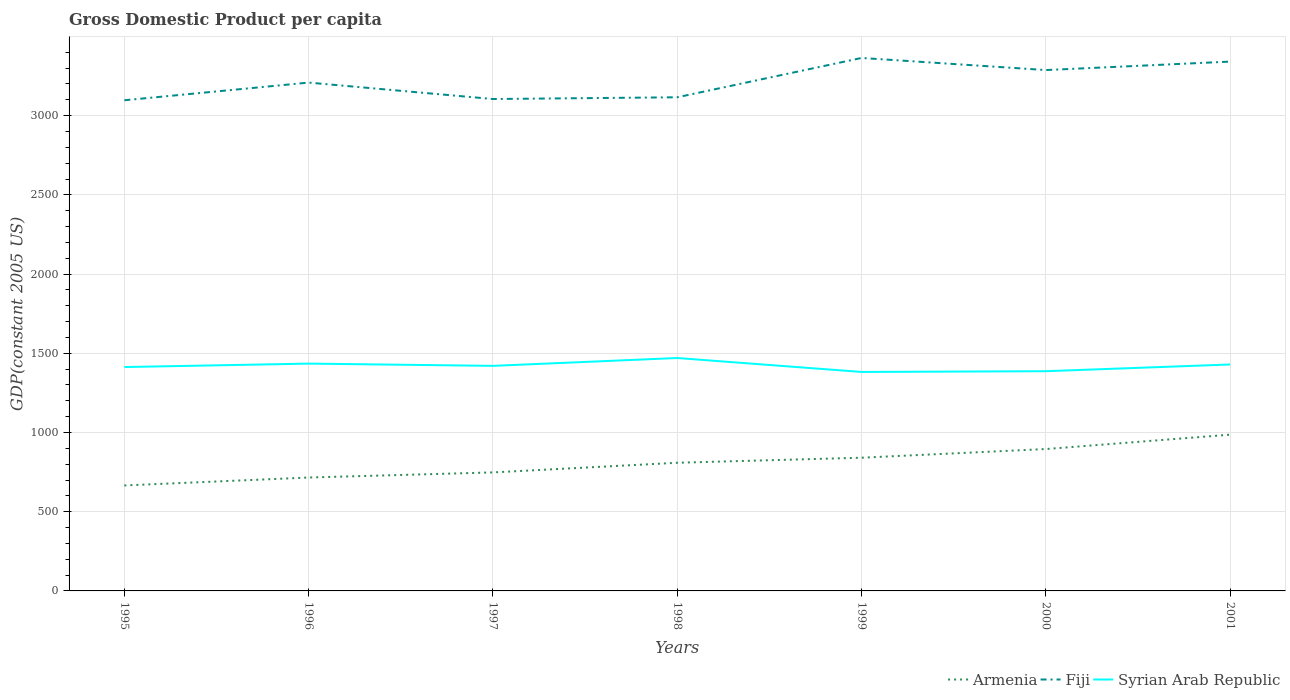Does the line corresponding to Syrian Arab Republic intersect with the line corresponding to Fiji?
Give a very brief answer. No. Is the number of lines equal to the number of legend labels?
Your response must be concise. Yes. Across all years, what is the maximum GDP per capita in Armenia?
Your answer should be very brief. 665.72. What is the total GDP per capita in Fiji in the graph?
Give a very brief answer. -267.04. What is the difference between the highest and the second highest GDP per capita in Syrian Arab Republic?
Your response must be concise. 88.08. What is the difference between the highest and the lowest GDP per capita in Syrian Arab Republic?
Offer a very short reply. 4. How many years are there in the graph?
Give a very brief answer. 7. Are the values on the major ticks of Y-axis written in scientific E-notation?
Offer a very short reply. No. Does the graph contain any zero values?
Make the answer very short. No. Does the graph contain grids?
Your answer should be very brief. Yes. Where does the legend appear in the graph?
Provide a short and direct response. Bottom right. How many legend labels are there?
Provide a succinct answer. 3. How are the legend labels stacked?
Provide a short and direct response. Horizontal. What is the title of the graph?
Your response must be concise. Gross Domestic Product per capita. What is the label or title of the X-axis?
Offer a very short reply. Years. What is the label or title of the Y-axis?
Give a very brief answer. GDP(constant 2005 US). What is the GDP(constant 2005 US) of Armenia in 1995?
Give a very brief answer. 665.72. What is the GDP(constant 2005 US) of Fiji in 1995?
Offer a very short reply. 3097.15. What is the GDP(constant 2005 US) of Syrian Arab Republic in 1995?
Ensure brevity in your answer.  1413.15. What is the GDP(constant 2005 US) of Armenia in 1996?
Make the answer very short. 715.82. What is the GDP(constant 2005 US) of Fiji in 1996?
Your answer should be very brief. 3208.65. What is the GDP(constant 2005 US) in Syrian Arab Republic in 1996?
Give a very brief answer. 1434.86. What is the GDP(constant 2005 US) in Armenia in 1997?
Give a very brief answer. 748.02. What is the GDP(constant 2005 US) in Fiji in 1997?
Make the answer very short. 3104.89. What is the GDP(constant 2005 US) in Syrian Arab Republic in 1997?
Your response must be concise. 1420.6. What is the GDP(constant 2005 US) in Armenia in 1998?
Keep it short and to the point. 809. What is the GDP(constant 2005 US) of Fiji in 1998?
Offer a terse response. 3115.96. What is the GDP(constant 2005 US) of Syrian Arab Republic in 1998?
Make the answer very short. 1470.19. What is the GDP(constant 2005 US) of Armenia in 1999?
Offer a very short reply. 840.86. What is the GDP(constant 2005 US) in Fiji in 1999?
Offer a very short reply. 3364.19. What is the GDP(constant 2005 US) of Syrian Arab Republic in 1999?
Make the answer very short. 1382.11. What is the GDP(constant 2005 US) in Armenia in 2000?
Offer a terse response. 895.6. What is the GDP(constant 2005 US) in Fiji in 2000?
Your response must be concise. 3287.72. What is the GDP(constant 2005 US) of Syrian Arab Republic in 2000?
Provide a succinct answer. 1386.88. What is the GDP(constant 2005 US) in Armenia in 2001?
Your answer should be compact. 986.34. What is the GDP(constant 2005 US) of Fiji in 2001?
Keep it short and to the point. 3341.15. What is the GDP(constant 2005 US) of Syrian Arab Republic in 2001?
Your answer should be very brief. 1429.27. Across all years, what is the maximum GDP(constant 2005 US) of Armenia?
Make the answer very short. 986.34. Across all years, what is the maximum GDP(constant 2005 US) in Fiji?
Your answer should be compact. 3364.19. Across all years, what is the maximum GDP(constant 2005 US) in Syrian Arab Republic?
Offer a very short reply. 1470.19. Across all years, what is the minimum GDP(constant 2005 US) in Armenia?
Your answer should be compact. 665.72. Across all years, what is the minimum GDP(constant 2005 US) in Fiji?
Provide a short and direct response. 3097.15. Across all years, what is the minimum GDP(constant 2005 US) in Syrian Arab Republic?
Give a very brief answer. 1382.11. What is the total GDP(constant 2005 US) of Armenia in the graph?
Give a very brief answer. 5661.37. What is the total GDP(constant 2005 US) in Fiji in the graph?
Your answer should be very brief. 2.25e+04. What is the total GDP(constant 2005 US) in Syrian Arab Republic in the graph?
Your answer should be compact. 9937.06. What is the difference between the GDP(constant 2005 US) in Armenia in 1995 and that in 1996?
Provide a short and direct response. -50.1. What is the difference between the GDP(constant 2005 US) of Fiji in 1995 and that in 1996?
Your response must be concise. -111.5. What is the difference between the GDP(constant 2005 US) of Syrian Arab Republic in 1995 and that in 1996?
Your response must be concise. -21.71. What is the difference between the GDP(constant 2005 US) of Armenia in 1995 and that in 1997?
Ensure brevity in your answer.  -82.3. What is the difference between the GDP(constant 2005 US) in Fiji in 1995 and that in 1997?
Keep it short and to the point. -7.75. What is the difference between the GDP(constant 2005 US) of Syrian Arab Republic in 1995 and that in 1997?
Provide a short and direct response. -7.45. What is the difference between the GDP(constant 2005 US) in Armenia in 1995 and that in 1998?
Your response must be concise. -143.27. What is the difference between the GDP(constant 2005 US) of Fiji in 1995 and that in 1998?
Give a very brief answer. -18.81. What is the difference between the GDP(constant 2005 US) of Syrian Arab Republic in 1995 and that in 1998?
Provide a short and direct response. -57.04. What is the difference between the GDP(constant 2005 US) of Armenia in 1995 and that in 1999?
Give a very brief answer. -175.14. What is the difference between the GDP(constant 2005 US) of Fiji in 1995 and that in 1999?
Your response must be concise. -267.04. What is the difference between the GDP(constant 2005 US) in Syrian Arab Republic in 1995 and that in 1999?
Your answer should be very brief. 31.04. What is the difference between the GDP(constant 2005 US) in Armenia in 1995 and that in 2000?
Provide a succinct answer. -229.88. What is the difference between the GDP(constant 2005 US) in Fiji in 1995 and that in 2000?
Your answer should be very brief. -190.57. What is the difference between the GDP(constant 2005 US) in Syrian Arab Republic in 1995 and that in 2000?
Your response must be concise. 26.27. What is the difference between the GDP(constant 2005 US) of Armenia in 1995 and that in 2001?
Ensure brevity in your answer.  -320.62. What is the difference between the GDP(constant 2005 US) in Fiji in 1995 and that in 2001?
Your response must be concise. -244. What is the difference between the GDP(constant 2005 US) of Syrian Arab Republic in 1995 and that in 2001?
Make the answer very short. -16.12. What is the difference between the GDP(constant 2005 US) of Armenia in 1996 and that in 1997?
Offer a terse response. -32.21. What is the difference between the GDP(constant 2005 US) of Fiji in 1996 and that in 1997?
Make the answer very short. 103.76. What is the difference between the GDP(constant 2005 US) in Syrian Arab Republic in 1996 and that in 1997?
Provide a succinct answer. 14.25. What is the difference between the GDP(constant 2005 US) of Armenia in 1996 and that in 1998?
Your response must be concise. -93.18. What is the difference between the GDP(constant 2005 US) of Fiji in 1996 and that in 1998?
Give a very brief answer. 92.69. What is the difference between the GDP(constant 2005 US) in Syrian Arab Republic in 1996 and that in 1998?
Give a very brief answer. -35.33. What is the difference between the GDP(constant 2005 US) of Armenia in 1996 and that in 1999?
Keep it short and to the point. -125.04. What is the difference between the GDP(constant 2005 US) of Fiji in 1996 and that in 1999?
Offer a very short reply. -155.53. What is the difference between the GDP(constant 2005 US) in Syrian Arab Republic in 1996 and that in 1999?
Your response must be concise. 52.75. What is the difference between the GDP(constant 2005 US) in Armenia in 1996 and that in 2000?
Give a very brief answer. -179.79. What is the difference between the GDP(constant 2005 US) in Fiji in 1996 and that in 2000?
Your answer should be very brief. -79.06. What is the difference between the GDP(constant 2005 US) in Syrian Arab Republic in 1996 and that in 2000?
Make the answer very short. 47.97. What is the difference between the GDP(constant 2005 US) in Armenia in 1996 and that in 2001?
Offer a very short reply. -270.53. What is the difference between the GDP(constant 2005 US) of Fiji in 1996 and that in 2001?
Provide a succinct answer. -132.5. What is the difference between the GDP(constant 2005 US) of Syrian Arab Republic in 1996 and that in 2001?
Give a very brief answer. 5.59. What is the difference between the GDP(constant 2005 US) of Armenia in 1997 and that in 1998?
Provide a short and direct response. -60.97. What is the difference between the GDP(constant 2005 US) of Fiji in 1997 and that in 1998?
Your answer should be compact. -11.07. What is the difference between the GDP(constant 2005 US) of Syrian Arab Republic in 1997 and that in 1998?
Your response must be concise. -49.58. What is the difference between the GDP(constant 2005 US) of Armenia in 1997 and that in 1999?
Give a very brief answer. -92.84. What is the difference between the GDP(constant 2005 US) of Fiji in 1997 and that in 1999?
Provide a short and direct response. -259.29. What is the difference between the GDP(constant 2005 US) of Syrian Arab Republic in 1997 and that in 1999?
Ensure brevity in your answer.  38.5. What is the difference between the GDP(constant 2005 US) in Armenia in 1997 and that in 2000?
Give a very brief answer. -147.58. What is the difference between the GDP(constant 2005 US) in Fiji in 1997 and that in 2000?
Give a very brief answer. -182.82. What is the difference between the GDP(constant 2005 US) of Syrian Arab Republic in 1997 and that in 2000?
Your answer should be compact. 33.72. What is the difference between the GDP(constant 2005 US) of Armenia in 1997 and that in 2001?
Offer a terse response. -238.32. What is the difference between the GDP(constant 2005 US) in Fiji in 1997 and that in 2001?
Offer a terse response. -236.25. What is the difference between the GDP(constant 2005 US) of Syrian Arab Republic in 1997 and that in 2001?
Ensure brevity in your answer.  -8.66. What is the difference between the GDP(constant 2005 US) of Armenia in 1998 and that in 1999?
Keep it short and to the point. -31.87. What is the difference between the GDP(constant 2005 US) of Fiji in 1998 and that in 1999?
Provide a succinct answer. -248.23. What is the difference between the GDP(constant 2005 US) in Syrian Arab Republic in 1998 and that in 1999?
Provide a short and direct response. 88.08. What is the difference between the GDP(constant 2005 US) of Armenia in 1998 and that in 2000?
Give a very brief answer. -86.61. What is the difference between the GDP(constant 2005 US) in Fiji in 1998 and that in 2000?
Ensure brevity in your answer.  -171.76. What is the difference between the GDP(constant 2005 US) of Syrian Arab Republic in 1998 and that in 2000?
Your response must be concise. 83.3. What is the difference between the GDP(constant 2005 US) of Armenia in 1998 and that in 2001?
Your response must be concise. -177.35. What is the difference between the GDP(constant 2005 US) in Fiji in 1998 and that in 2001?
Make the answer very short. -225.19. What is the difference between the GDP(constant 2005 US) of Syrian Arab Republic in 1998 and that in 2001?
Your answer should be compact. 40.92. What is the difference between the GDP(constant 2005 US) in Armenia in 1999 and that in 2000?
Ensure brevity in your answer.  -54.74. What is the difference between the GDP(constant 2005 US) in Fiji in 1999 and that in 2000?
Provide a short and direct response. 76.47. What is the difference between the GDP(constant 2005 US) of Syrian Arab Republic in 1999 and that in 2000?
Give a very brief answer. -4.77. What is the difference between the GDP(constant 2005 US) of Armenia in 1999 and that in 2001?
Provide a succinct answer. -145.48. What is the difference between the GDP(constant 2005 US) of Fiji in 1999 and that in 2001?
Make the answer very short. 23.04. What is the difference between the GDP(constant 2005 US) in Syrian Arab Republic in 1999 and that in 2001?
Offer a very short reply. -47.16. What is the difference between the GDP(constant 2005 US) of Armenia in 2000 and that in 2001?
Ensure brevity in your answer.  -90.74. What is the difference between the GDP(constant 2005 US) in Fiji in 2000 and that in 2001?
Make the answer very short. -53.43. What is the difference between the GDP(constant 2005 US) in Syrian Arab Republic in 2000 and that in 2001?
Your answer should be compact. -42.38. What is the difference between the GDP(constant 2005 US) of Armenia in 1995 and the GDP(constant 2005 US) of Fiji in 1996?
Provide a short and direct response. -2542.93. What is the difference between the GDP(constant 2005 US) of Armenia in 1995 and the GDP(constant 2005 US) of Syrian Arab Republic in 1996?
Provide a short and direct response. -769.13. What is the difference between the GDP(constant 2005 US) in Fiji in 1995 and the GDP(constant 2005 US) in Syrian Arab Republic in 1996?
Keep it short and to the point. 1662.29. What is the difference between the GDP(constant 2005 US) in Armenia in 1995 and the GDP(constant 2005 US) in Fiji in 1997?
Keep it short and to the point. -2439.17. What is the difference between the GDP(constant 2005 US) of Armenia in 1995 and the GDP(constant 2005 US) of Syrian Arab Republic in 1997?
Provide a succinct answer. -754.88. What is the difference between the GDP(constant 2005 US) in Fiji in 1995 and the GDP(constant 2005 US) in Syrian Arab Republic in 1997?
Your response must be concise. 1676.54. What is the difference between the GDP(constant 2005 US) of Armenia in 1995 and the GDP(constant 2005 US) of Fiji in 1998?
Your answer should be compact. -2450.24. What is the difference between the GDP(constant 2005 US) in Armenia in 1995 and the GDP(constant 2005 US) in Syrian Arab Republic in 1998?
Keep it short and to the point. -804.46. What is the difference between the GDP(constant 2005 US) of Fiji in 1995 and the GDP(constant 2005 US) of Syrian Arab Republic in 1998?
Keep it short and to the point. 1626.96. What is the difference between the GDP(constant 2005 US) of Armenia in 1995 and the GDP(constant 2005 US) of Fiji in 1999?
Ensure brevity in your answer.  -2698.46. What is the difference between the GDP(constant 2005 US) of Armenia in 1995 and the GDP(constant 2005 US) of Syrian Arab Republic in 1999?
Your response must be concise. -716.39. What is the difference between the GDP(constant 2005 US) of Fiji in 1995 and the GDP(constant 2005 US) of Syrian Arab Republic in 1999?
Provide a short and direct response. 1715.04. What is the difference between the GDP(constant 2005 US) of Armenia in 1995 and the GDP(constant 2005 US) of Fiji in 2000?
Offer a terse response. -2621.99. What is the difference between the GDP(constant 2005 US) of Armenia in 1995 and the GDP(constant 2005 US) of Syrian Arab Republic in 2000?
Offer a terse response. -721.16. What is the difference between the GDP(constant 2005 US) in Fiji in 1995 and the GDP(constant 2005 US) in Syrian Arab Republic in 2000?
Provide a short and direct response. 1710.27. What is the difference between the GDP(constant 2005 US) in Armenia in 1995 and the GDP(constant 2005 US) in Fiji in 2001?
Provide a short and direct response. -2675.43. What is the difference between the GDP(constant 2005 US) of Armenia in 1995 and the GDP(constant 2005 US) of Syrian Arab Republic in 2001?
Provide a short and direct response. -763.54. What is the difference between the GDP(constant 2005 US) in Fiji in 1995 and the GDP(constant 2005 US) in Syrian Arab Republic in 2001?
Offer a very short reply. 1667.88. What is the difference between the GDP(constant 2005 US) of Armenia in 1996 and the GDP(constant 2005 US) of Fiji in 1997?
Offer a very short reply. -2389.08. What is the difference between the GDP(constant 2005 US) of Armenia in 1996 and the GDP(constant 2005 US) of Syrian Arab Republic in 1997?
Provide a succinct answer. -704.79. What is the difference between the GDP(constant 2005 US) of Fiji in 1996 and the GDP(constant 2005 US) of Syrian Arab Republic in 1997?
Offer a very short reply. 1788.05. What is the difference between the GDP(constant 2005 US) in Armenia in 1996 and the GDP(constant 2005 US) in Fiji in 1998?
Keep it short and to the point. -2400.14. What is the difference between the GDP(constant 2005 US) of Armenia in 1996 and the GDP(constant 2005 US) of Syrian Arab Republic in 1998?
Provide a short and direct response. -754.37. What is the difference between the GDP(constant 2005 US) in Fiji in 1996 and the GDP(constant 2005 US) in Syrian Arab Republic in 1998?
Offer a very short reply. 1738.46. What is the difference between the GDP(constant 2005 US) of Armenia in 1996 and the GDP(constant 2005 US) of Fiji in 1999?
Your response must be concise. -2648.37. What is the difference between the GDP(constant 2005 US) of Armenia in 1996 and the GDP(constant 2005 US) of Syrian Arab Republic in 1999?
Provide a short and direct response. -666.29. What is the difference between the GDP(constant 2005 US) in Fiji in 1996 and the GDP(constant 2005 US) in Syrian Arab Republic in 1999?
Provide a succinct answer. 1826.54. What is the difference between the GDP(constant 2005 US) in Armenia in 1996 and the GDP(constant 2005 US) in Fiji in 2000?
Your answer should be very brief. -2571.9. What is the difference between the GDP(constant 2005 US) in Armenia in 1996 and the GDP(constant 2005 US) in Syrian Arab Republic in 2000?
Make the answer very short. -671.06. What is the difference between the GDP(constant 2005 US) in Fiji in 1996 and the GDP(constant 2005 US) in Syrian Arab Republic in 2000?
Provide a succinct answer. 1821.77. What is the difference between the GDP(constant 2005 US) of Armenia in 1996 and the GDP(constant 2005 US) of Fiji in 2001?
Your answer should be very brief. -2625.33. What is the difference between the GDP(constant 2005 US) of Armenia in 1996 and the GDP(constant 2005 US) of Syrian Arab Republic in 2001?
Your response must be concise. -713.45. What is the difference between the GDP(constant 2005 US) in Fiji in 1996 and the GDP(constant 2005 US) in Syrian Arab Republic in 2001?
Your response must be concise. 1779.38. What is the difference between the GDP(constant 2005 US) in Armenia in 1997 and the GDP(constant 2005 US) in Fiji in 1998?
Provide a succinct answer. -2367.94. What is the difference between the GDP(constant 2005 US) in Armenia in 1997 and the GDP(constant 2005 US) in Syrian Arab Republic in 1998?
Your response must be concise. -722.16. What is the difference between the GDP(constant 2005 US) of Fiji in 1997 and the GDP(constant 2005 US) of Syrian Arab Republic in 1998?
Make the answer very short. 1634.71. What is the difference between the GDP(constant 2005 US) in Armenia in 1997 and the GDP(constant 2005 US) in Fiji in 1999?
Give a very brief answer. -2616.16. What is the difference between the GDP(constant 2005 US) in Armenia in 1997 and the GDP(constant 2005 US) in Syrian Arab Republic in 1999?
Make the answer very short. -634.09. What is the difference between the GDP(constant 2005 US) of Fiji in 1997 and the GDP(constant 2005 US) of Syrian Arab Republic in 1999?
Offer a terse response. 1722.79. What is the difference between the GDP(constant 2005 US) in Armenia in 1997 and the GDP(constant 2005 US) in Fiji in 2000?
Your answer should be very brief. -2539.69. What is the difference between the GDP(constant 2005 US) in Armenia in 1997 and the GDP(constant 2005 US) in Syrian Arab Republic in 2000?
Provide a short and direct response. -638.86. What is the difference between the GDP(constant 2005 US) in Fiji in 1997 and the GDP(constant 2005 US) in Syrian Arab Republic in 2000?
Provide a succinct answer. 1718.01. What is the difference between the GDP(constant 2005 US) of Armenia in 1997 and the GDP(constant 2005 US) of Fiji in 2001?
Offer a very short reply. -2593.12. What is the difference between the GDP(constant 2005 US) of Armenia in 1997 and the GDP(constant 2005 US) of Syrian Arab Republic in 2001?
Keep it short and to the point. -681.24. What is the difference between the GDP(constant 2005 US) in Fiji in 1997 and the GDP(constant 2005 US) in Syrian Arab Republic in 2001?
Your answer should be very brief. 1675.63. What is the difference between the GDP(constant 2005 US) in Armenia in 1998 and the GDP(constant 2005 US) in Fiji in 1999?
Give a very brief answer. -2555.19. What is the difference between the GDP(constant 2005 US) in Armenia in 1998 and the GDP(constant 2005 US) in Syrian Arab Republic in 1999?
Your response must be concise. -573.11. What is the difference between the GDP(constant 2005 US) in Fiji in 1998 and the GDP(constant 2005 US) in Syrian Arab Republic in 1999?
Your answer should be compact. 1733.85. What is the difference between the GDP(constant 2005 US) in Armenia in 1998 and the GDP(constant 2005 US) in Fiji in 2000?
Offer a terse response. -2478.72. What is the difference between the GDP(constant 2005 US) of Armenia in 1998 and the GDP(constant 2005 US) of Syrian Arab Republic in 2000?
Offer a terse response. -577.89. What is the difference between the GDP(constant 2005 US) of Fiji in 1998 and the GDP(constant 2005 US) of Syrian Arab Republic in 2000?
Offer a terse response. 1729.08. What is the difference between the GDP(constant 2005 US) of Armenia in 1998 and the GDP(constant 2005 US) of Fiji in 2001?
Ensure brevity in your answer.  -2532.15. What is the difference between the GDP(constant 2005 US) in Armenia in 1998 and the GDP(constant 2005 US) in Syrian Arab Republic in 2001?
Your response must be concise. -620.27. What is the difference between the GDP(constant 2005 US) of Fiji in 1998 and the GDP(constant 2005 US) of Syrian Arab Republic in 2001?
Ensure brevity in your answer.  1686.69. What is the difference between the GDP(constant 2005 US) in Armenia in 1999 and the GDP(constant 2005 US) in Fiji in 2000?
Give a very brief answer. -2446.85. What is the difference between the GDP(constant 2005 US) in Armenia in 1999 and the GDP(constant 2005 US) in Syrian Arab Republic in 2000?
Provide a short and direct response. -546.02. What is the difference between the GDP(constant 2005 US) of Fiji in 1999 and the GDP(constant 2005 US) of Syrian Arab Republic in 2000?
Ensure brevity in your answer.  1977.3. What is the difference between the GDP(constant 2005 US) of Armenia in 1999 and the GDP(constant 2005 US) of Fiji in 2001?
Provide a succinct answer. -2500.29. What is the difference between the GDP(constant 2005 US) in Armenia in 1999 and the GDP(constant 2005 US) in Syrian Arab Republic in 2001?
Keep it short and to the point. -588.4. What is the difference between the GDP(constant 2005 US) of Fiji in 1999 and the GDP(constant 2005 US) of Syrian Arab Republic in 2001?
Ensure brevity in your answer.  1934.92. What is the difference between the GDP(constant 2005 US) in Armenia in 2000 and the GDP(constant 2005 US) in Fiji in 2001?
Keep it short and to the point. -2445.54. What is the difference between the GDP(constant 2005 US) of Armenia in 2000 and the GDP(constant 2005 US) of Syrian Arab Republic in 2001?
Make the answer very short. -533.66. What is the difference between the GDP(constant 2005 US) of Fiji in 2000 and the GDP(constant 2005 US) of Syrian Arab Republic in 2001?
Make the answer very short. 1858.45. What is the average GDP(constant 2005 US) of Armenia per year?
Provide a short and direct response. 808.77. What is the average GDP(constant 2005 US) of Fiji per year?
Your answer should be compact. 3217.1. What is the average GDP(constant 2005 US) of Syrian Arab Republic per year?
Your answer should be very brief. 1419.58. In the year 1995, what is the difference between the GDP(constant 2005 US) of Armenia and GDP(constant 2005 US) of Fiji?
Your answer should be compact. -2431.43. In the year 1995, what is the difference between the GDP(constant 2005 US) of Armenia and GDP(constant 2005 US) of Syrian Arab Republic?
Offer a terse response. -747.43. In the year 1995, what is the difference between the GDP(constant 2005 US) in Fiji and GDP(constant 2005 US) in Syrian Arab Republic?
Your answer should be very brief. 1684. In the year 1996, what is the difference between the GDP(constant 2005 US) in Armenia and GDP(constant 2005 US) in Fiji?
Offer a terse response. -2492.83. In the year 1996, what is the difference between the GDP(constant 2005 US) in Armenia and GDP(constant 2005 US) in Syrian Arab Republic?
Your answer should be compact. -719.04. In the year 1996, what is the difference between the GDP(constant 2005 US) of Fiji and GDP(constant 2005 US) of Syrian Arab Republic?
Keep it short and to the point. 1773.8. In the year 1997, what is the difference between the GDP(constant 2005 US) of Armenia and GDP(constant 2005 US) of Fiji?
Keep it short and to the point. -2356.87. In the year 1997, what is the difference between the GDP(constant 2005 US) in Armenia and GDP(constant 2005 US) in Syrian Arab Republic?
Ensure brevity in your answer.  -672.58. In the year 1997, what is the difference between the GDP(constant 2005 US) in Fiji and GDP(constant 2005 US) in Syrian Arab Republic?
Ensure brevity in your answer.  1684.29. In the year 1998, what is the difference between the GDP(constant 2005 US) in Armenia and GDP(constant 2005 US) in Fiji?
Offer a terse response. -2306.96. In the year 1998, what is the difference between the GDP(constant 2005 US) in Armenia and GDP(constant 2005 US) in Syrian Arab Republic?
Make the answer very short. -661.19. In the year 1998, what is the difference between the GDP(constant 2005 US) in Fiji and GDP(constant 2005 US) in Syrian Arab Republic?
Offer a very short reply. 1645.77. In the year 1999, what is the difference between the GDP(constant 2005 US) in Armenia and GDP(constant 2005 US) in Fiji?
Provide a succinct answer. -2523.32. In the year 1999, what is the difference between the GDP(constant 2005 US) in Armenia and GDP(constant 2005 US) in Syrian Arab Republic?
Your answer should be compact. -541.25. In the year 1999, what is the difference between the GDP(constant 2005 US) of Fiji and GDP(constant 2005 US) of Syrian Arab Republic?
Provide a short and direct response. 1982.08. In the year 2000, what is the difference between the GDP(constant 2005 US) in Armenia and GDP(constant 2005 US) in Fiji?
Provide a short and direct response. -2392.11. In the year 2000, what is the difference between the GDP(constant 2005 US) in Armenia and GDP(constant 2005 US) in Syrian Arab Republic?
Give a very brief answer. -491.28. In the year 2000, what is the difference between the GDP(constant 2005 US) of Fiji and GDP(constant 2005 US) of Syrian Arab Republic?
Ensure brevity in your answer.  1900.83. In the year 2001, what is the difference between the GDP(constant 2005 US) in Armenia and GDP(constant 2005 US) in Fiji?
Provide a succinct answer. -2354.8. In the year 2001, what is the difference between the GDP(constant 2005 US) of Armenia and GDP(constant 2005 US) of Syrian Arab Republic?
Your response must be concise. -442.92. In the year 2001, what is the difference between the GDP(constant 2005 US) in Fiji and GDP(constant 2005 US) in Syrian Arab Republic?
Keep it short and to the point. 1911.88. What is the ratio of the GDP(constant 2005 US) in Armenia in 1995 to that in 1996?
Your answer should be very brief. 0.93. What is the ratio of the GDP(constant 2005 US) of Fiji in 1995 to that in 1996?
Ensure brevity in your answer.  0.97. What is the ratio of the GDP(constant 2005 US) of Syrian Arab Republic in 1995 to that in 1996?
Your response must be concise. 0.98. What is the ratio of the GDP(constant 2005 US) of Armenia in 1995 to that in 1997?
Your answer should be compact. 0.89. What is the ratio of the GDP(constant 2005 US) in Armenia in 1995 to that in 1998?
Keep it short and to the point. 0.82. What is the ratio of the GDP(constant 2005 US) in Fiji in 1995 to that in 1998?
Keep it short and to the point. 0.99. What is the ratio of the GDP(constant 2005 US) of Syrian Arab Republic in 1995 to that in 1998?
Keep it short and to the point. 0.96. What is the ratio of the GDP(constant 2005 US) in Armenia in 1995 to that in 1999?
Make the answer very short. 0.79. What is the ratio of the GDP(constant 2005 US) of Fiji in 1995 to that in 1999?
Make the answer very short. 0.92. What is the ratio of the GDP(constant 2005 US) of Syrian Arab Republic in 1995 to that in 1999?
Your answer should be compact. 1.02. What is the ratio of the GDP(constant 2005 US) in Armenia in 1995 to that in 2000?
Offer a very short reply. 0.74. What is the ratio of the GDP(constant 2005 US) in Fiji in 1995 to that in 2000?
Make the answer very short. 0.94. What is the ratio of the GDP(constant 2005 US) of Syrian Arab Republic in 1995 to that in 2000?
Offer a very short reply. 1.02. What is the ratio of the GDP(constant 2005 US) in Armenia in 1995 to that in 2001?
Your answer should be very brief. 0.67. What is the ratio of the GDP(constant 2005 US) of Fiji in 1995 to that in 2001?
Your answer should be very brief. 0.93. What is the ratio of the GDP(constant 2005 US) of Syrian Arab Republic in 1995 to that in 2001?
Ensure brevity in your answer.  0.99. What is the ratio of the GDP(constant 2005 US) in Armenia in 1996 to that in 1997?
Your response must be concise. 0.96. What is the ratio of the GDP(constant 2005 US) in Fiji in 1996 to that in 1997?
Provide a short and direct response. 1.03. What is the ratio of the GDP(constant 2005 US) in Syrian Arab Republic in 1996 to that in 1997?
Ensure brevity in your answer.  1.01. What is the ratio of the GDP(constant 2005 US) of Armenia in 1996 to that in 1998?
Your answer should be very brief. 0.88. What is the ratio of the GDP(constant 2005 US) in Fiji in 1996 to that in 1998?
Offer a very short reply. 1.03. What is the ratio of the GDP(constant 2005 US) of Syrian Arab Republic in 1996 to that in 1998?
Your answer should be compact. 0.98. What is the ratio of the GDP(constant 2005 US) of Armenia in 1996 to that in 1999?
Keep it short and to the point. 0.85. What is the ratio of the GDP(constant 2005 US) in Fiji in 1996 to that in 1999?
Provide a short and direct response. 0.95. What is the ratio of the GDP(constant 2005 US) of Syrian Arab Republic in 1996 to that in 1999?
Give a very brief answer. 1.04. What is the ratio of the GDP(constant 2005 US) of Armenia in 1996 to that in 2000?
Offer a very short reply. 0.8. What is the ratio of the GDP(constant 2005 US) in Fiji in 1996 to that in 2000?
Your answer should be compact. 0.98. What is the ratio of the GDP(constant 2005 US) in Syrian Arab Republic in 1996 to that in 2000?
Provide a short and direct response. 1.03. What is the ratio of the GDP(constant 2005 US) of Armenia in 1996 to that in 2001?
Give a very brief answer. 0.73. What is the ratio of the GDP(constant 2005 US) of Fiji in 1996 to that in 2001?
Make the answer very short. 0.96. What is the ratio of the GDP(constant 2005 US) in Syrian Arab Republic in 1996 to that in 2001?
Ensure brevity in your answer.  1. What is the ratio of the GDP(constant 2005 US) of Armenia in 1997 to that in 1998?
Offer a very short reply. 0.92. What is the ratio of the GDP(constant 2005 US) in Syrian Arab Republic in 1997 to that in 1998?
Give a very brief answer. 0.97. What is the ratio of the GDP(constant 2005 US) of Armenia in 1997 to that in 1999?
Your response must be concise. 0.89. What is the ratio of the GDP(constant 2005 US) in Fiji in 1997 to that in 1999?
Provide a succinct answer. 0.92. What is the ratio of the GDP(constant 2005 US) in Syrian Arab Republic in 1997 to that in 1999?
Keep it short and to the point. 1.03. What is the ratio of the GDP(constant 2005 US) of Armenia in 1997 to that in 2000?
Your response must be concise. 0.84. What is the ratio of the GDP(constant 2005 US) of Fiji in 1997 to that in 2000?
Offer a very short reply. 0.94. What is the ratio of the GDP(constant 2005 US) of Syrian Arab Republic in 1997 to that in 2000?
Your answer should be compact. 1.02. What is the ratio of the GDP(constant 2005 US) of Armenia in 1997 to that in 2001?
Your answer should be very brief. 0.76. What is the ratio of the GDP(constant 2005 US) in Fiji in 1997 to that in 2001?
Offer a terse response. 0.93. What is the ratio of the GDP(constant 2005 US) of Syrian Arab Republic in 1997 to that in 2001?
Your response must be concise. 0.99. What is the ratio of the GDP(constant 2005 US) in Armenia in 1998 to that in 1999?
Your answer should be compact. 0.96. What is the ratio of the GDP(constant 2005 US) of Fiji in 1998 to that in 1999?
Keep it short and to the point. 0.93. What is the ratio of the GDP(constant 2005 US) in Syrian Arab Republic in 1998 to that in 1999?
Make the answer very short. 1.06. What is the ratio of the GDP(constant 2005 US) of Armenia in 1998 to that in 2000?
Offer a terse response. 0.9. What is the ratio of the GDP(constant 2005 US) in Fiji in 1998 to that in 2000?
Give a very brief answer. 0.95. What is the ratio of the GDP(constant 2005 US) of Syrian Arab Republic in 1998 to that in 2000?
Provide a short and direct response. 1.06. What is the ratio of the GDP(constant 2005 US) in Armenia in 1998 to that in 2001?
Provide a short and direct response. 0.82. What is the ratio of the GDP(constant 2005 US) in Fiji in 1998 to that in 2001?
Give a very brief answer. 0.93. What is the ratio of the GDP(constant 2005 US) of Syrian Arab Republic in 1998 to that in 2001?
Make the answer very short. 1.03. What is the ratio of the GDP(constant 2005 US) of Armenia in 1999 to that in 2000?
Keep it short and to the point. 0.94. What is the ratio of the GDP(constant 2005 US) in Fiji in 1999 to that in 2000?
Your answer should be compact. 1.02. What is the ratio of the GDP(constant 2005 US) in Armenia in 1999 to that in 2001?
Offer a terse response. 0.85. What is the ratio of the GDP(constant 2005 US) of Syrian Arab Republic in 1999 to that in 2001?
Your answer should be compact. 0.97. What is the ratio of the GDP(constant 2005 US) of Armenia in 2000 to that in 2001?
Your answer should be compact. 0.91. What is the ratio of the GDP(constant 2005 US) in Fiji in 2000 to that in 2001?
Offer a terse response. 0.98. What is the ratio of the GDP(constant 2005 US) in Syrian Arab Republic in 2000 to that in 2001?
Offer a terse response. 0.97. What is the difference between the highest and the second highest GDP(constant 2005 US) in Armenia?
Keep it short and to the point. 90.74. What is the difference between the highest and the second highest GDP(constant 2005 US) in Fiji?
Keep it short and to the point. 23.04. What is the difference between the highest and the second highest GDP(constant 2005 US) of Syrian Arab Republic?
Make the answer very short. 35.33. What is the difference between the highest and the lowest GDP(constant 2005 US) of Armenia?
Your answer should be compact. 320.62. What is the difference between the highest and the lowest GDP(constant 2005 US) of Fiji?
Offer a terse response. 267.04. What is the difference between the highest and the lowest GDP(constant 2005 US) in Syrian Arab Republic?
Ensure brevity in your answer.  88.08. 